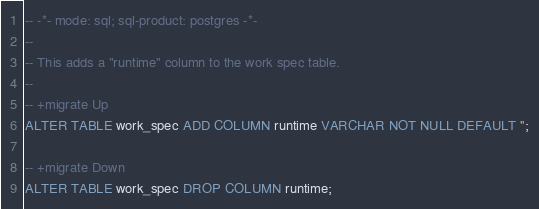Convert code to text. <code><loc_0><loc_0><loc_500><loc_500><_SQL_>-- -*- mode: sql; sql-product: postgres -*-
--
-- This adds a "runtime" column to the work spec table.
--
-- +migrate Up
ALTER TABLE work_spec ADD COLUMN runtime VARCHAR NOT NULL DEFAULT '';

-- +migrate Down
ALTER TABLE work_spec DROP COLUMN runtime;
</code> 